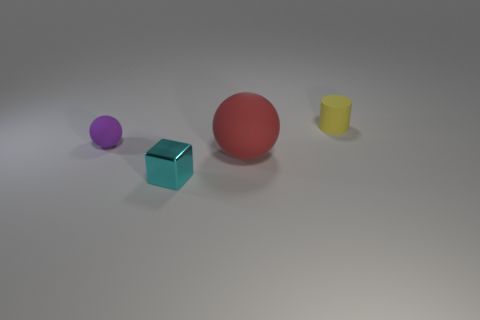Are there any small cyan cubes made of the same material as the purple object?
Offer a terse response. No. What number of things are either matte things that are right of the cyan object or small gray rubber cubes?
Offer a terse response. 2. Is the ball right of the tiny cyan thing made of the same material as the cube?
Make the answer very short. No. Does the tiny purple object have the same shape as the big red rubber thing?
Keep it short and to the point. Yes. What number of spheres are behind the rubber thing in front of the tiny rubber ball?
Offer a terse response. 1. What material is the other thing that is the same shape as the large thing?
Provide a short and direct response. Rubber. Does the purple ball have the same material as the sphere in front of the tiny purple ball?
Give a very brief answer. Yes. The tiny rubber thing on the left side of the large ball has what shape?
Your answer should be compact. Sphere. What number of other objects are there of the same material as the yellow cylinder?
Give a very brief answer. 2. The red object has what size?
Provide a succinct answer. Large. 